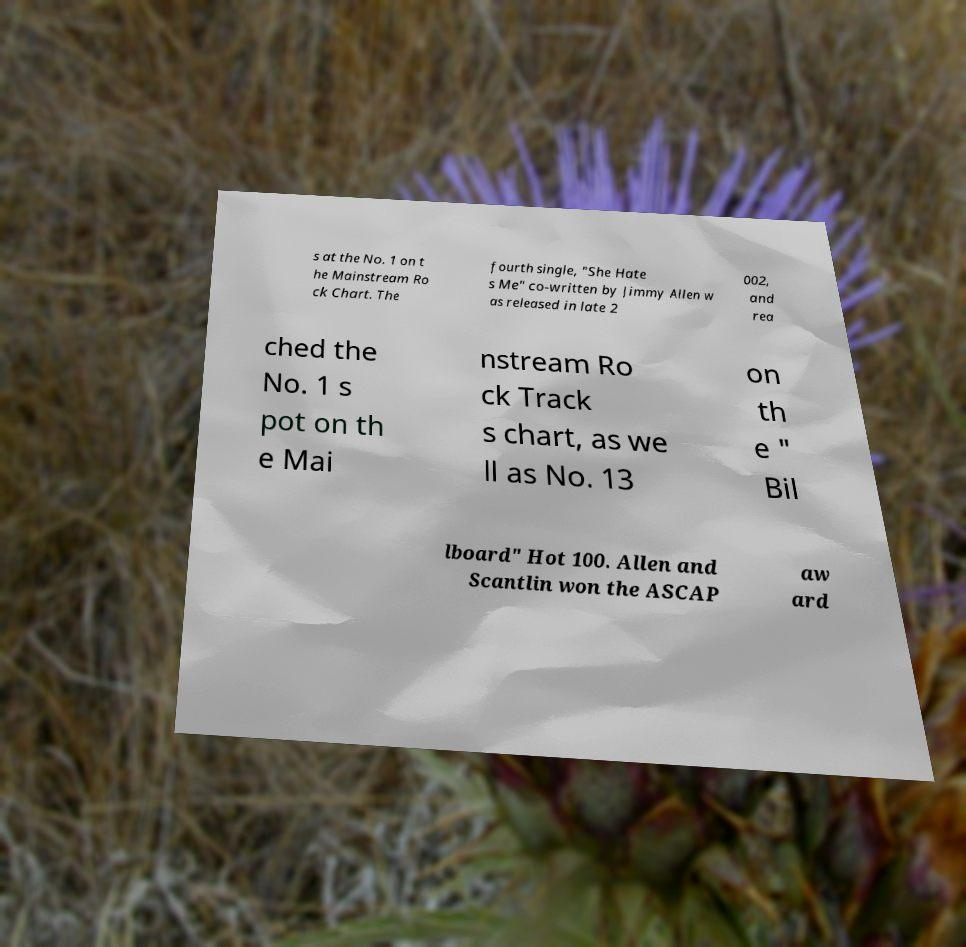Can you read and provide the text displayed in the image?This photo seems to have some interesting text. Can you extract and type it out for me? s at the No. 1 on t he Mainstream Ro ck Chart. The fourth single, "She Hate s Me" co-written by Jimmy Allen w as released in late 2 002, and rea ched the No. 1 s pot on th e Mai nstream Ro ck Track s chart, as we ll as No. 13 on th e " Bil lboard" Hot 100. Allen and Scantlin won the ASCAP aw ard 